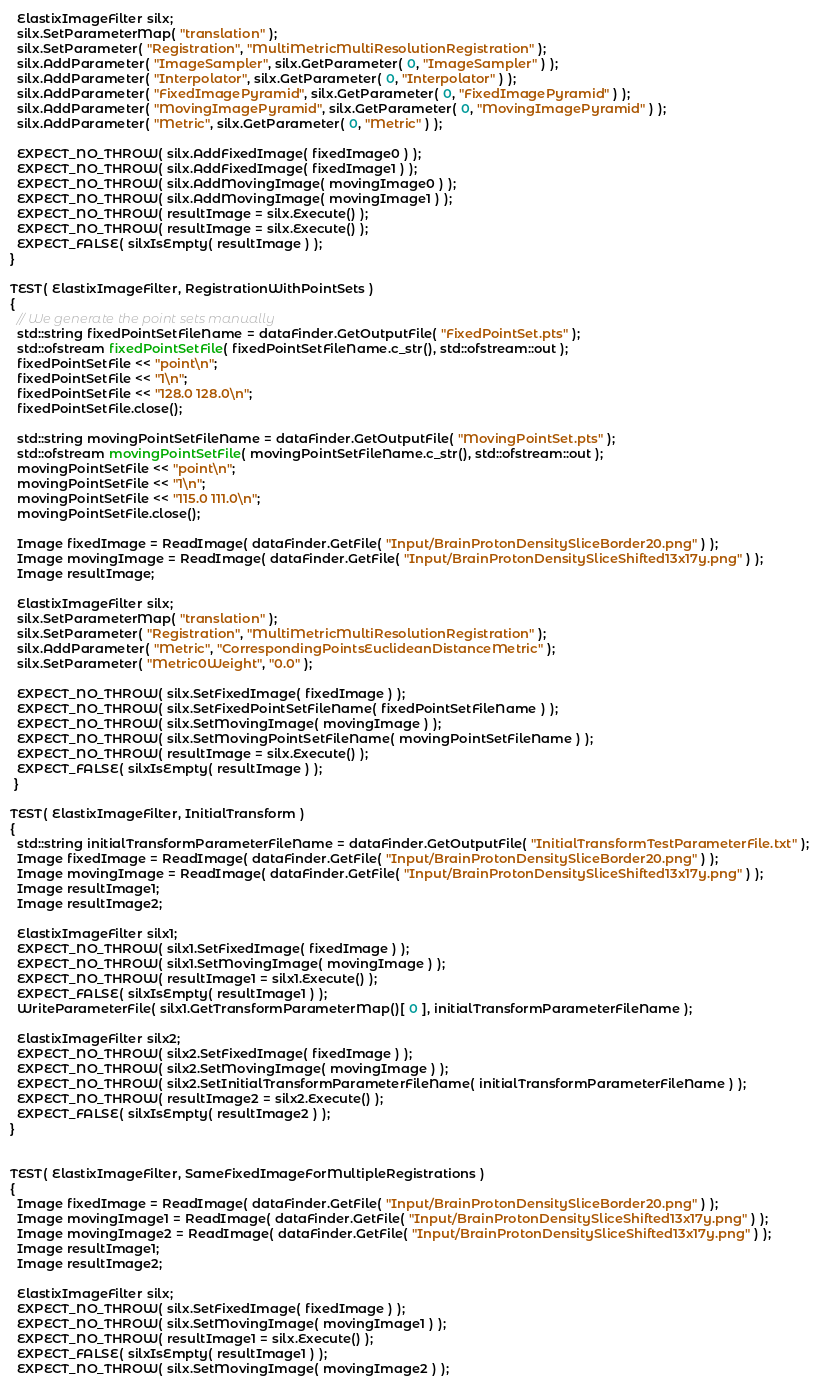Convert code to text. <code><loc_0><loc_0><loc_500><loc_500><_C++_>  ElastixImageFilter silx;
  silx.SetParameterMap( "translation" );
  silx.SetParameter( "Registration", "MultiMetricMultiResolutionRegistration" );
  silx.AddParameter( "ImageSampler", silx.GetParameter( 0, "ImageSampler" ) );
  silx.AddParameter( "Interpolator", silx.GetParameter( 0, "Interpolator" ) );
  silx.AddParameter( "FixedImagePyramid", silx.GetParameter( 0, "FixedImagePyramid" ) );
  silx.AddParameter( "MovingImagePyramid", silx.GetParameter( 0, "MovingImagePyramid" ) );
  silx.AddParameter( "Metric", silx.GetParameter( 0, "Metric" ) );

  EXPECT_NO_THROW( silx.AddFixedImage( fixedImage0 ) );
  EXPECT_NO_THROW( silx.AddFixedImage( fixedImage1 ) );
  EXPECT_NO_THROW( silx.AddMovingImage( movingImage0 ) );
  EXPECT_NO_THROW( silx.AddMovingImage( movingImage1 ) );
  EXPECT_NO_THROW( resultImage = silx.Execute() );
  EXPECT_NO_THROW( resultImage = silx.Execute() );
  EXPECT_FALSE( silxIsEmpty( resultImage ) );
}

TEST( ElastixImageFilter, RegistrationWithPointSets )
{
  // We generate the point sets manually
  std::string fixedPointSetFileName = dataFinder.GetOutputFile( "FixedPointSet.pts" );
  std::ofstream fixedPointSetFile( fixedPointSetFileName.c_str(), std::ofstream::out );
  fixedPointSetFile << "point\n";
  fixedPointSetFile << "1\n";
  fixedPointSetFile << "128.0 128.0\n";
  fixedPointSetFile.close();

  std::string movingPointSetFileName = dataFinder.GetOutputFile( "MovingPointSet.pts" );
  std::ofstream movingPointSetFile( movingPointSetFileName.c_str(), std::ofstream::out );
  movingPointSetFile << "point\n";
  movingPointSetFile << "1\n";
  movingPointSetFile << "115.0 111.0\n";
  movingPointSetFile.close();

  Image fixedImage = ReadImage( dataFinder.GetFile( "Input/BrainProtonDensitySliceBorder20.png" ) );
  Image movingImage = ReadImage( dataFinder.GetFile( "Input/BrainProtonDensitySliceShifted13x17y.png" ) );
  Image resultImage; 

  ElastixImageFilter silx;
  silx.SetParameterMap( "translation" );
  silx.SetParameter( "Registration", "MultiMetricMultiResolutionRegistration" );
  silx.AddParameter( "Metric", "CorrespondingPointsEuclideanDistanceMetric" );
  silx.SetParameter( "Metric0Weight", "0.0" );

  EXPECT_NO_THROW( silx.SetFixedImage( fixedImage ) );
  EXPECT_NO_THROW( silx.SetFixedPointSetFileName( fixedPointSetFileName ) );
  EXPECT_NO_THROW( silx.SetMovingImage( movingImage ) );
  EXPECT_NO_THROW( silx.SetMovingPointSetFileName( movingPointSetFileName ) );
  EXPECT_NO_THROW( resultImage = silx.Execute() );
  EXPECT_FALSE( silxIsEmpty( resultImage ) );
 }

TEST( ElastixImageFilter, InitialTransform )
{
  std::string initialTransformParameterFileName = dataFinder.GetOutputFile( "InitialTransformTestParameterFile.txt" );
  Image fixedImage = ReadImage( dataFinder.GetFile( "Input/BrainProtonDensitySliceBorder20.png" ) );
  Image movingImage = ReadImage( dataFinder.GetFile( "Input/BrainProtonDensitySliceShifted13x17y.png" ) );
  Image resultImage1; 
  Image resultImage2; 

  ElastixImageFilter silx1;
  EXPECT_NO_THROW( silx1.SetFixedImage( fixedImage ) );
  EXPECT_NO_THROW( silx1.SetMovingImage( movingImage ) );
  EXPECT_NO_THROW( resultImage1 = silx1.Execute() );
  EXPECT_FALSE( silxIsEmpty( resultImage1 ) );
  WriteParameterFile( silx1.GetTransformParameterMap()[ 0 ], initialTransformParameterFileName );

  ElastixImageFilter silx2;
  EXPECT_NO_THROW( silx2.SetFixedImage( fixedImage ) );
  EXPECT_NO_THROW( silx2.SetMovingImage( movingImage ) );
  EXPECT_NO_THROW( silx2.SetInitialTransformParameterFileName( initialTransformParameterFileName ) );
  EXPECT_NO_THROW( resultImage2 = silx2.Execute() );
  EXPECT_FALSE( silxIsEmpty( resultImage2 ) );
}


TEST( ElastixImageFilter, SameFixedImageForMultipleRegistrations )
{ 
  Image fixedImage = ReadImage( dataFinder.GetFile( "Input/BrainProtonDensitySliceBorder20.png" ) );
  Image movingImage1 = ReadImage( dataFinder.GetFile( "Input/BrainProtonDensitySliceShifted13x17y.png" ) );
  Image movingImage2 = ReadImage( dataFinder.GetFile( "Input/BrainProtonDensitySliceShifted13x17y.png" ) );
  Image resultImage1;
  Image resultImage2; 

  ElastixImageFilter silx;
  EXPECT_NO_THROW( silx.SetFixedImage( fixedImage ) );
  EXPECT_NO_THROW( silx.SetMovingImage( movingImage1 ) );
  EXPECT_NO_THROW( resultImage1 = silx.Execute() );
  EXPECT_FALSE( silxIsEmpty( resultImage1 ) );
  EXPECT_NO_THROW( silx.SetMovingImage( movingImage2 ) );</code> 